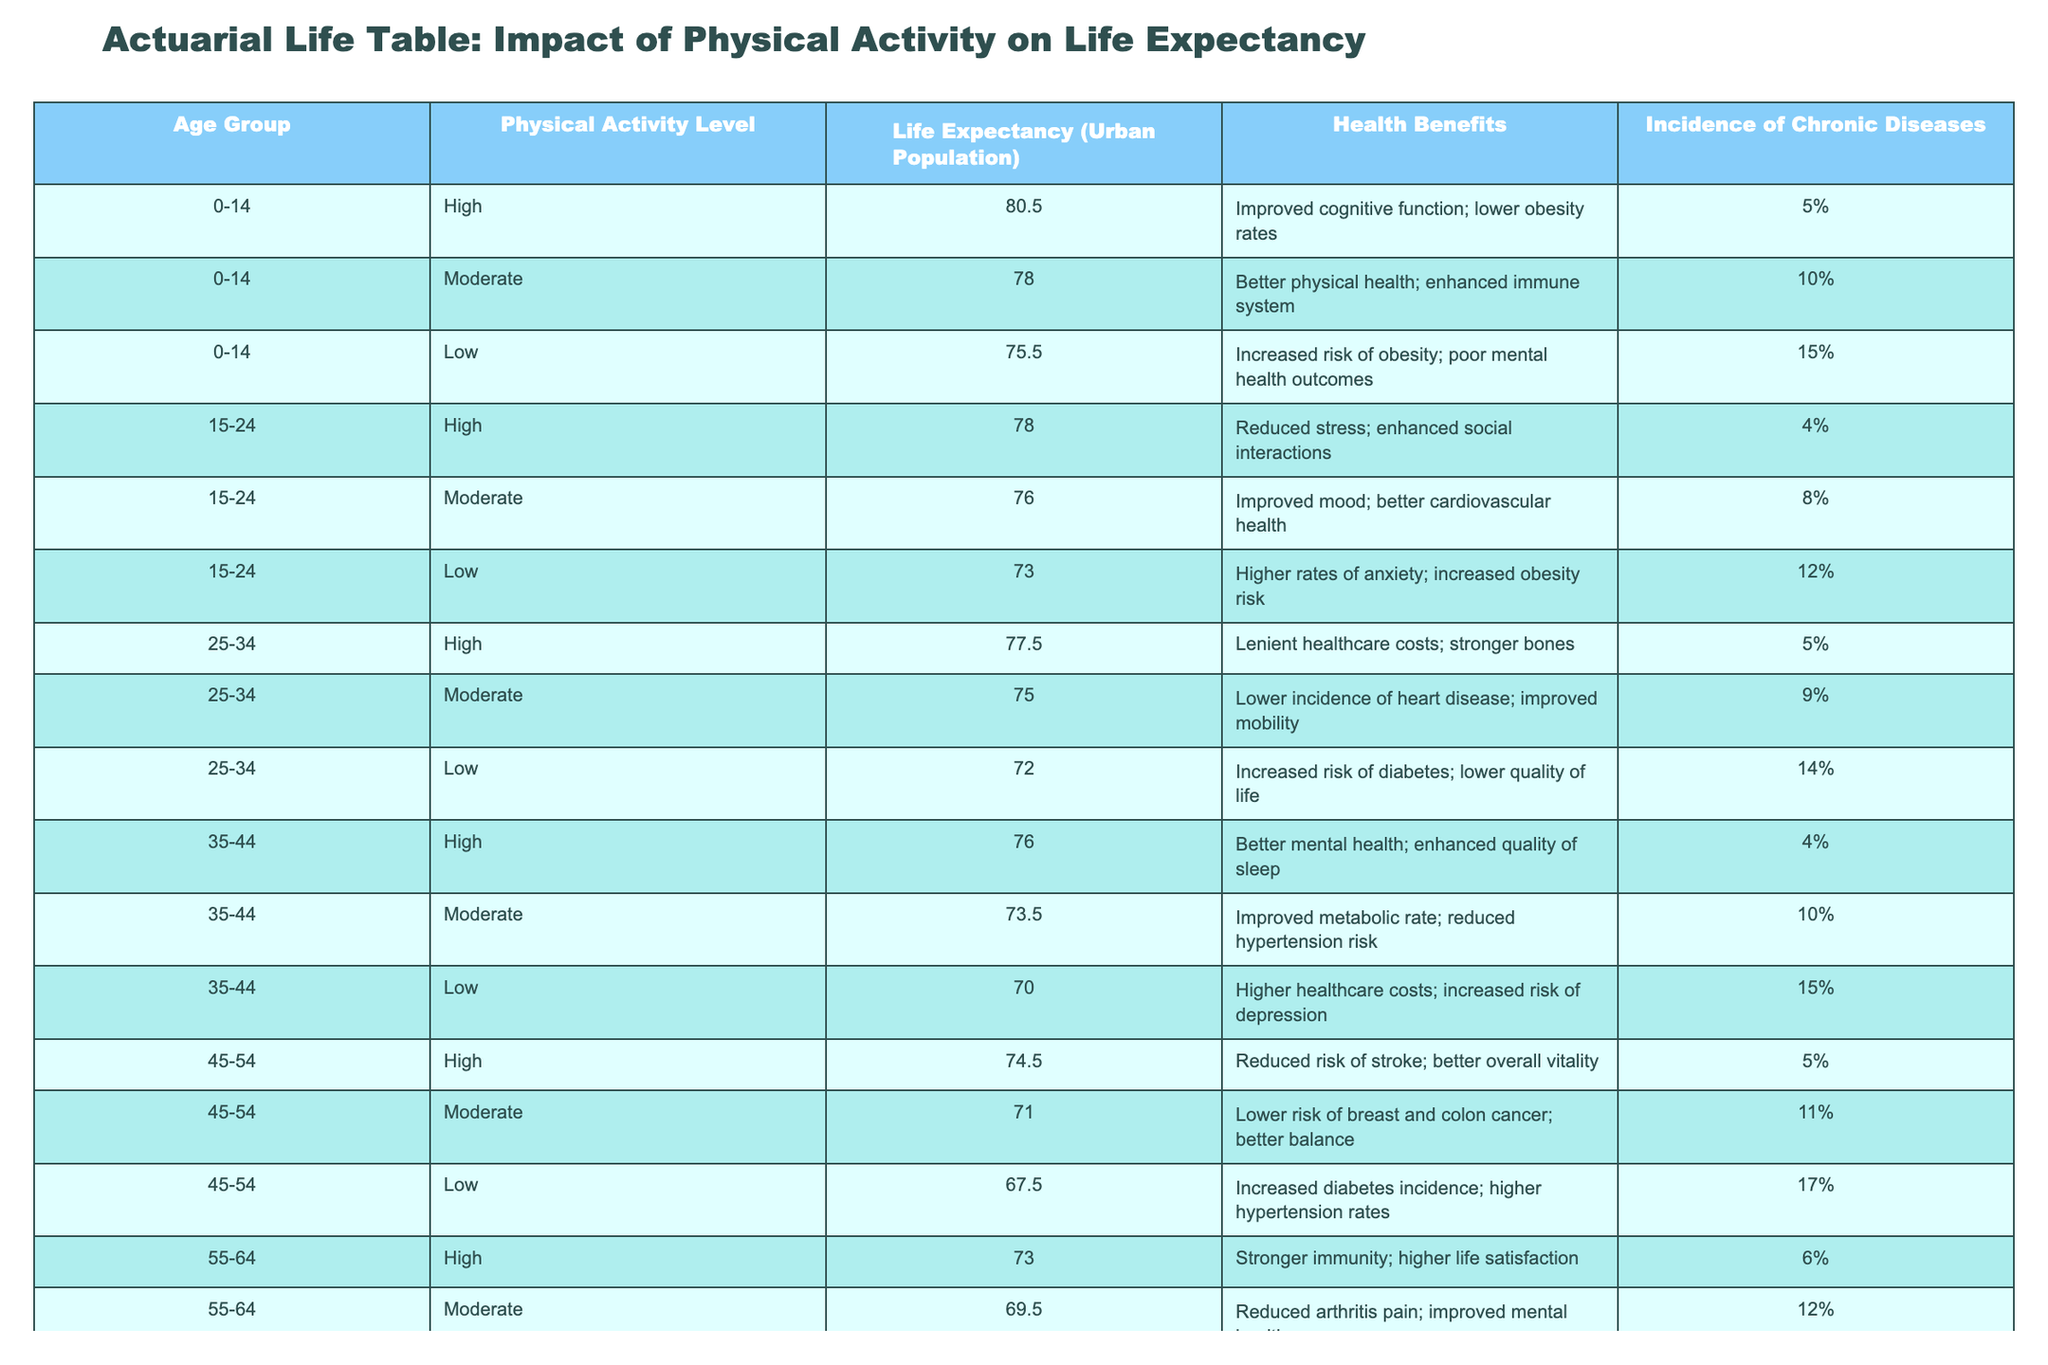What is the life expectancy for individuals aged 45-54 with a high level of physical activity? According to the table, the life expectancy for individuals aged 45-54 with a high level of physical activity is 74.5 years.
Answer: 74.5 What percentage of individuals aged 65 and above with low physical activity experience severe chronic illness risk? The table states that 25% of individuals aged 65 and above with low physical activity experience severe chronic illness risk.
Answer: 25% What is the life expectancy difference between individuals aged 15-24 with high versus low physical activity? For individuals aged 15-24, the life expectancy for those with high physical activity is 78.0 years and for those with low activity is 73.0 years. The difference is 5.0 years (78.0 - 73.0).
Answer: 5.0 Is it true that higher physical activity levels lead to lower incidences of chronic diseases in all age groups? The table provides information that supports this statement; however, the incidence of chronic diseases varies by age group and physical activity level. For example, individuals aged 0-14 with high activity have a 5% incidence, whereas those with low have 15%. This pattern holds in other age groups as well, indicating that more physical activity generally correlates with lower chronic diseases.
Answer: Yes What is the average life expectancy for individuals aged 55-64 across all physical activity levels? To calculate the average life expectancy for individuals aged 55-64, sum the life expectancies for high (73.0), moderate (69.5), and low (65.0) activity levels: 73.0 + 69.5 + 65.0 = 207.5. Now divide by the number of entries, which is 3. Therefore, the average life expectancy is 207.5/3 = 69.17.
Answer: 69.17 